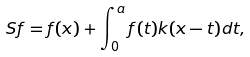Convert formula to latex. <formula><loc_0><loc_0><loc_500><loc_500>S f = f ( x ) + \int _ { 0 } ^ { a } f ( t ) k ( x - t ) d t ,</formula> 